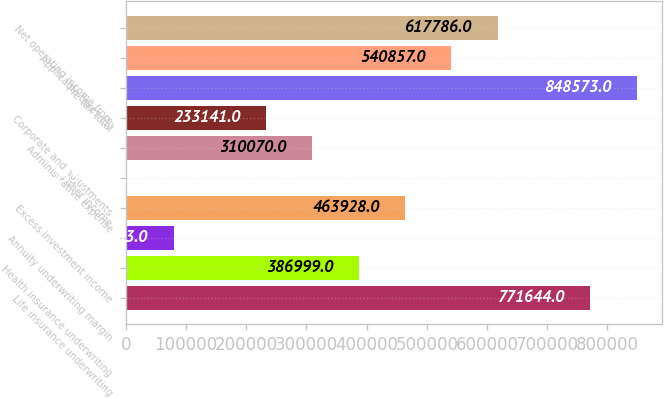<chart> <loc_0><loc_0><loc_500><loc_500><bar_chart><fcel>Life insurance underwriting<fcel>Health insurance underwriting<fcel>Annuity underwriting margin<fcel>Excess investment income<fcel>Other income<fcel>Administrative expense<fcel>Corporate and adjustments<fcel>Pre-tax total<fcel>Applicable taxes (1)<fcel>Net operating income from<nl><fcel>771644<fcel>386999<fcel>79283<fcel>463928<fcel>2354<fcel>310070<fcel>233141<fcel>848573<fcel>540857<fcel>617786<nl></chart> 